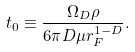Convert formula to latex. <formula><loc_0><loc_0><loc_500><loc_500>t _ { 0 } \equiv \frac { \Omega _ { D } \rho } { 6 \pi D \mu r _ { F } ^ { 1 - D } } .</formula> 